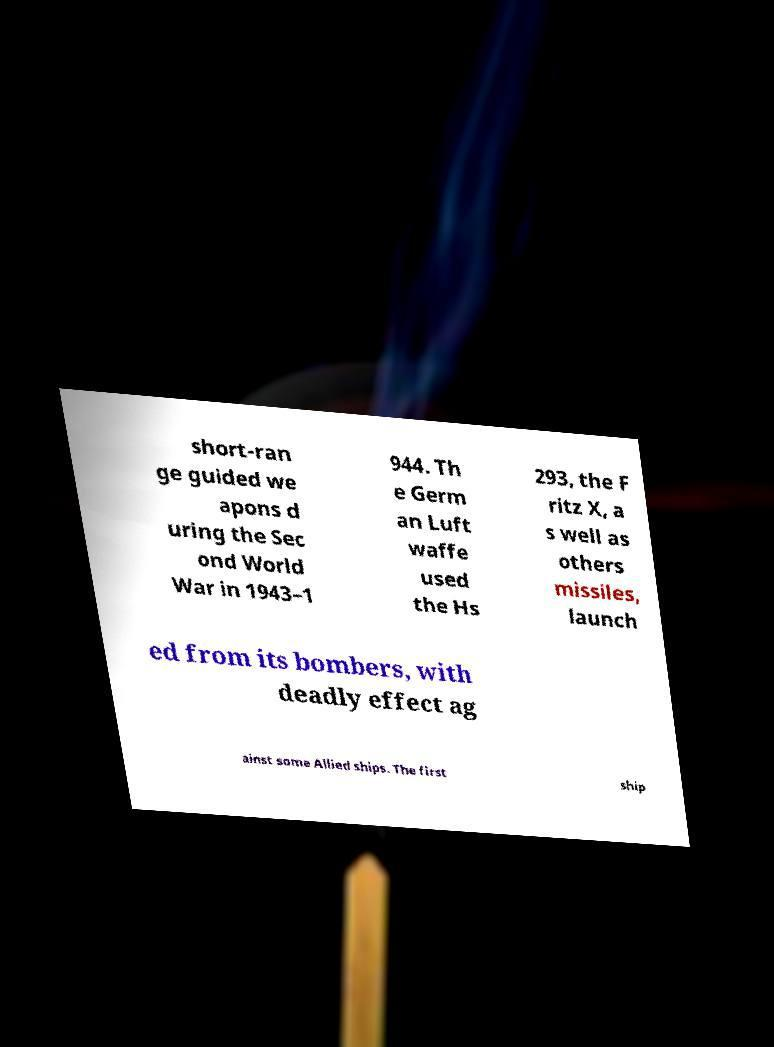Could you extract and type out the text from this image? short-ran ge guided we apons d uring the Sec ond World War in 1943–1 944. Th e Germ an Luft waffe used the Hs 293, the F ritz X, a s well as others missiles, launch ed from its bombers, with deadly effect ag ainst some Allied ships. The first ship 